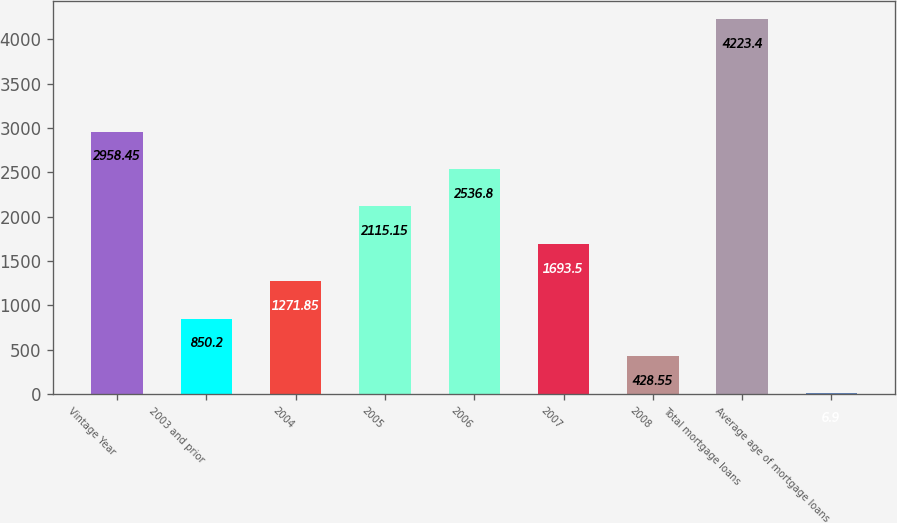<chart> <loc_0><loc_0><loc_500><loc_500><bar_chart><fcel>Vintage Year<fcel>2003 and prior<fcel>2004<fcel>2005<fcel>2006<fcel>2007<fcel>2008<fcel>Total mortgage loans<fcel>Average age of mortgage loans<nl><fcel>2958.45<fcel>850.2<fcel>1271.85<fcel>2115.15<fcel>2536.8<fcel>1693.5<fcel>428.55<fcel>4223.4<fcel>6.9<nl></chart> 